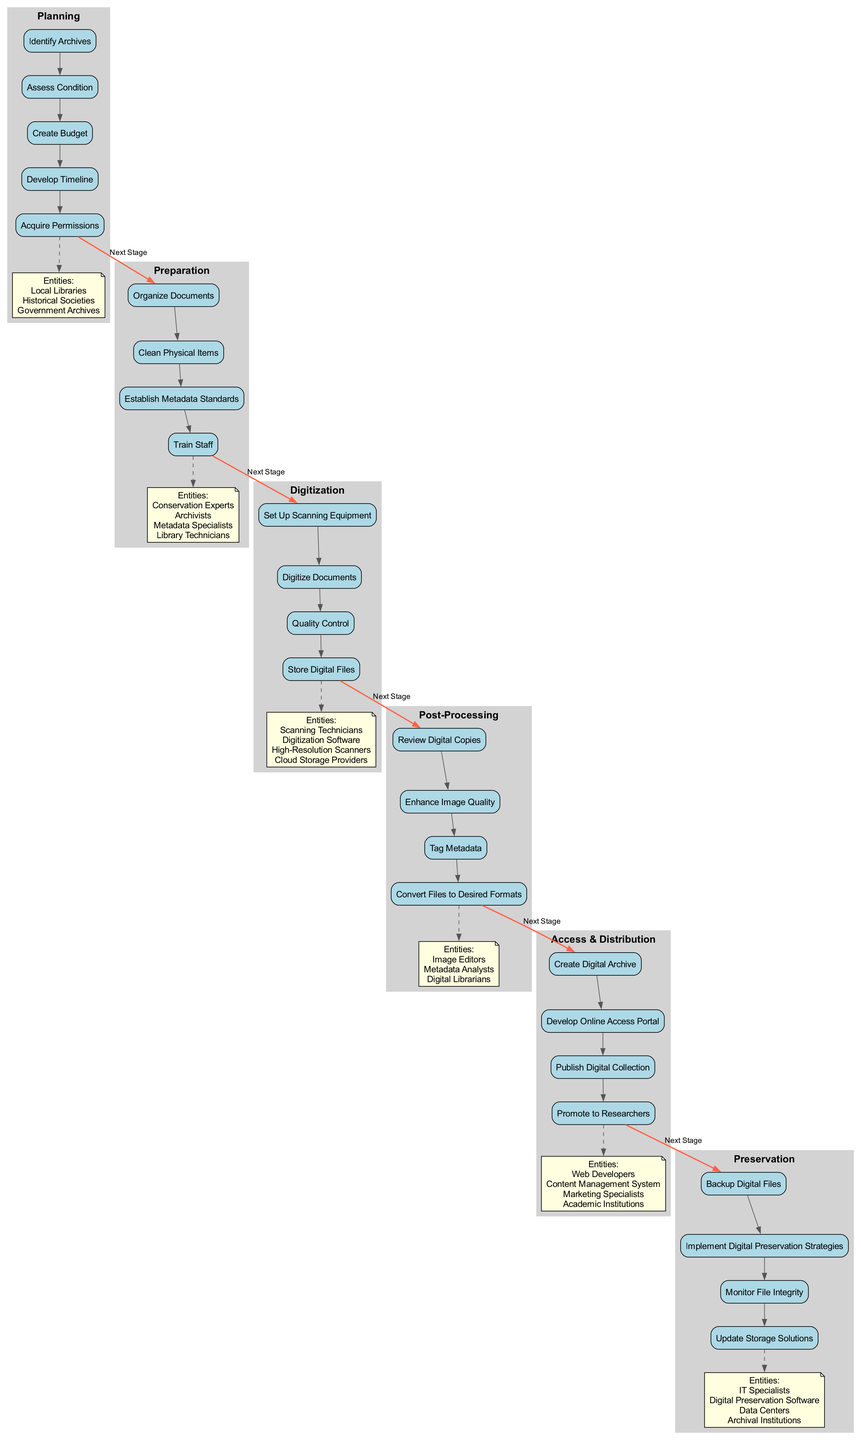What are the five stages in the Digitization Pathway? By examining the diagram, I can list the stages that are clustered together: Planning, Preparation, Digitization, Post-Processing, Access & Distribution, and Preservation.
Answer: Planning, Preparation, Digitization, Post-Processing, Access & Distribution, Preservation Which activity comes first in the Preparation stage? Looking at the activities within the Preparation stage, the first activity listed is "Organize Documents."
Answer: Organize Documents How many activities are listed under the Digitization stage? Counting the number of activities in the Digitization stage shows that there are four activities: Set Up Scanning Equipment, Digitize Documents, Quality Control, and Store Digital Files.
Answer: 4 What type of entities are associated with the Access & Distribution stage? Reviewing the entities listed under Access & Distribution, I find they include Web Developers, Content Management System, Marketing Specialists, and Academic Institutions.
Answer: Web Developers, Content Management System, Marketing Specialists, Academic Institutions Which stage follows Post-Processing? In the flow of the diagram, the stage that follows Post-Processing is Access & Distribution, as indicated by the bold connecting edge.
Answer: Access & Distribution What activities are related to Preservation? By analyzing the Preservation stage, the activities listed there are Backup Digital Files, Implement Digital Preservation Strategies, Monitor File Integrity, and Update Storage Solutions.
Answer: Backup Digital Files, Implement Digital Preservation Strategies, Monitor File Integrity, Update Storage Solutions How many entities are linked to the Planning stage? In the diagram, I observe that three entities are linked to the Planning stage: Local Libraries, Historical Societies, and Government Archives.
Answer: 3 Which activity finishes the Digitization stage? Looking at the activities in the Digitization stage, the final activity listed is "Store Digital Files."
Answer: Store Digital Files What is the relationship between the Post-Processing and Preservation stages? The relationship is indicated by the bold edge connecting the final activity of the Post-Processing stage (Enhance Image Quality) to the first activity of the Preservation stage (Backup Digital Files).
Answer: Next Stage 